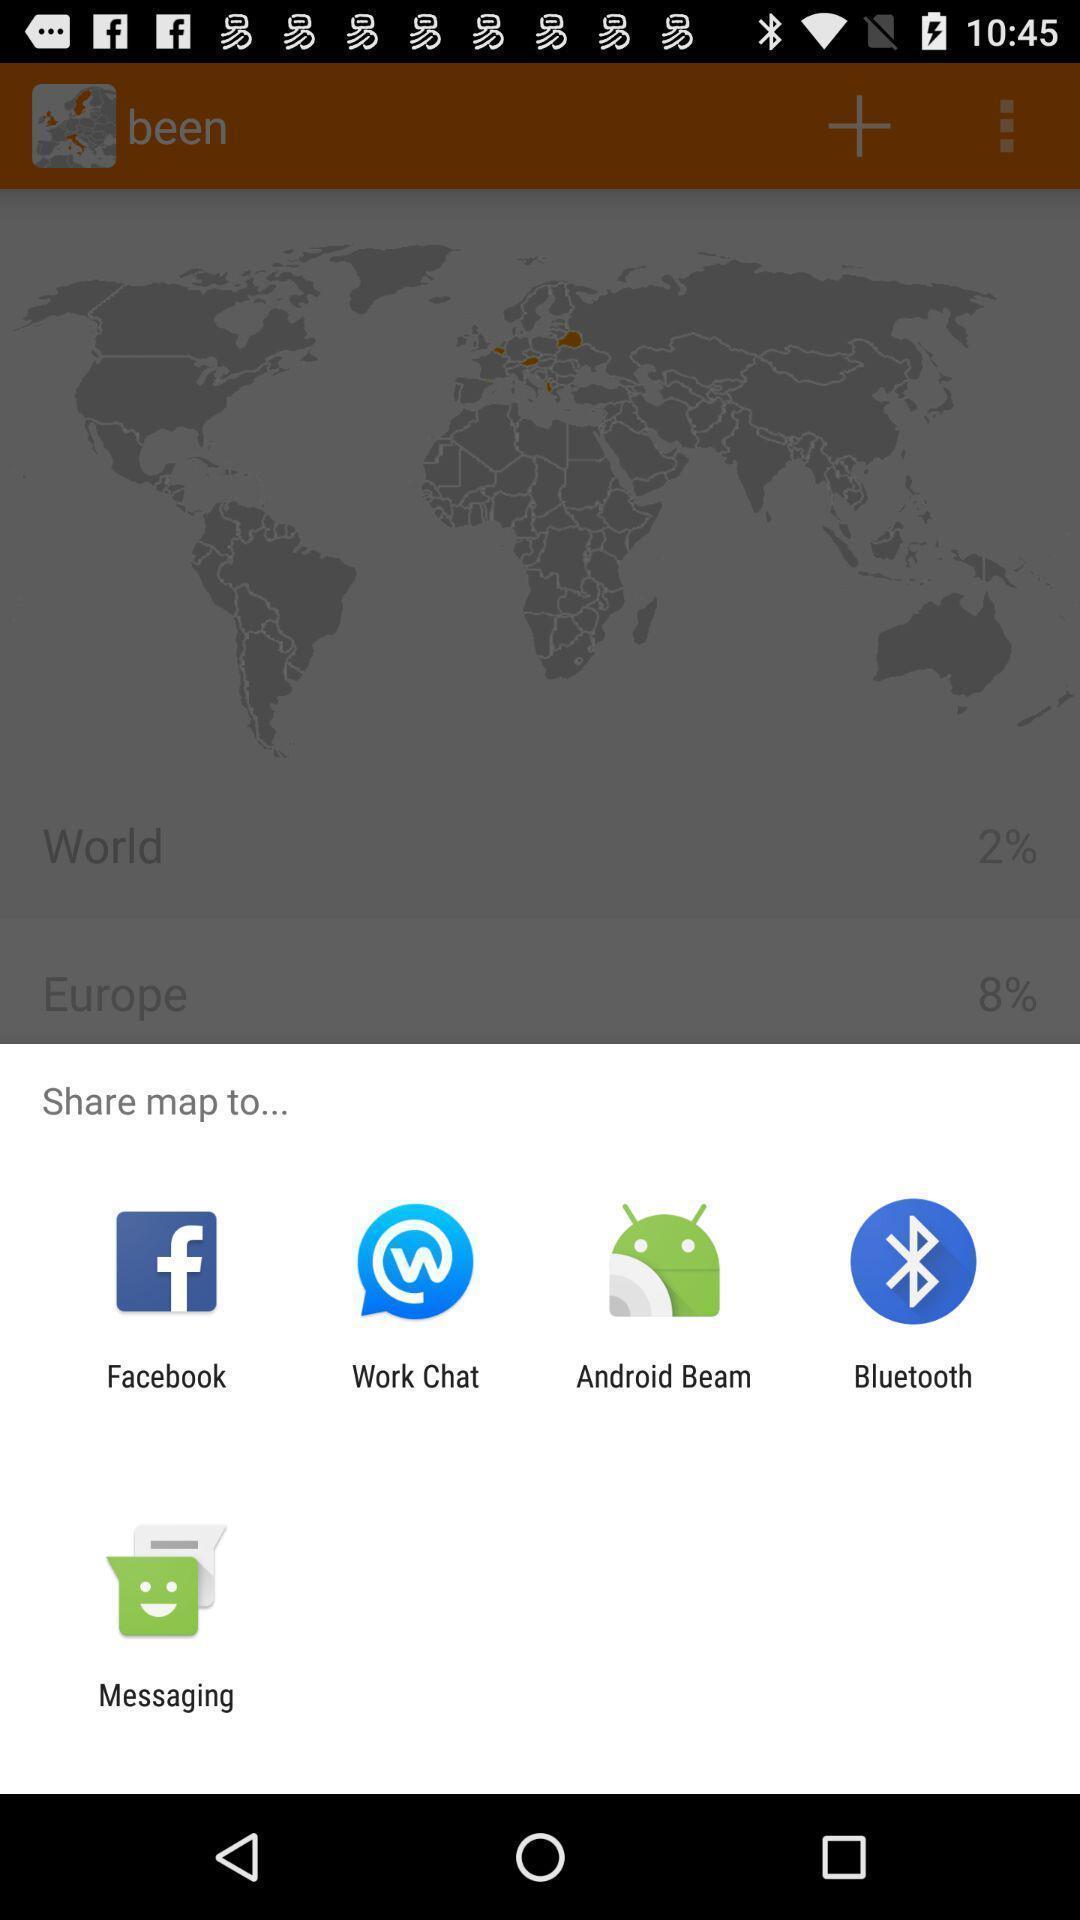Describe the content in this image. Pop-up displaying different social apps to share data. 